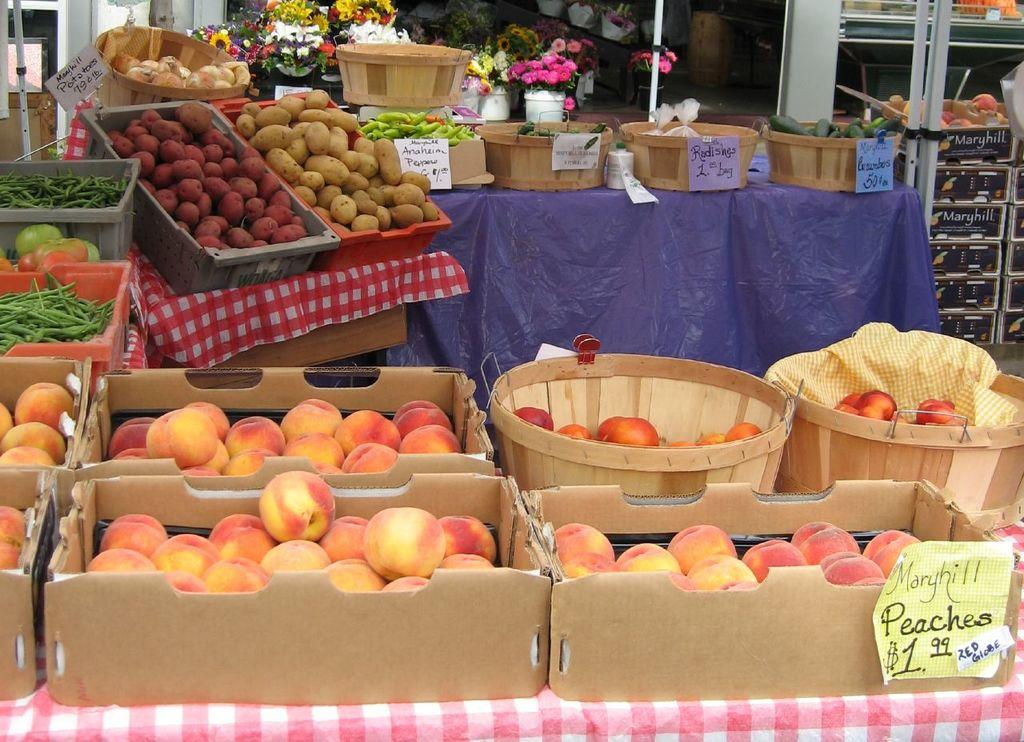What types of food items can be seen in the image? There are fruits and vegetables in the image. How are the fruits and vegetables arranged in the image? The fruits and vegetables are in baskets. What else can be seen in the image besides fruits and vegetables? There are flower pots visible in the image. What type of class is being taught in the image? There is no class or teaching activity depicted in the image; it features fruits, vegetables, and flower pots. What is the religious significance of the fruits and vegetables in the image? There is no religious context or significance associated with the fruits and vegetables in the image. 